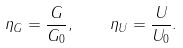<formula> <loc_0><loc_0><loc_500><loc_500>\eta _ { G } = \frac { G } { G _ { 0 } } , \quad \eta _ { U } = \frac { U } { U _ { 0 } } .</formula> 